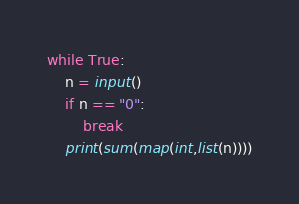Convert code to text. <code><loc_0><loc_0><loc_500><loc_500><_Python_>while True:
    n = input()
    if n == "0":
        break
    print(sum(map(int,list(n))))
</code> 